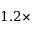<formula> <loc_0><loc_0><loc_500><loc_500>1 . 2 \times</formula> 